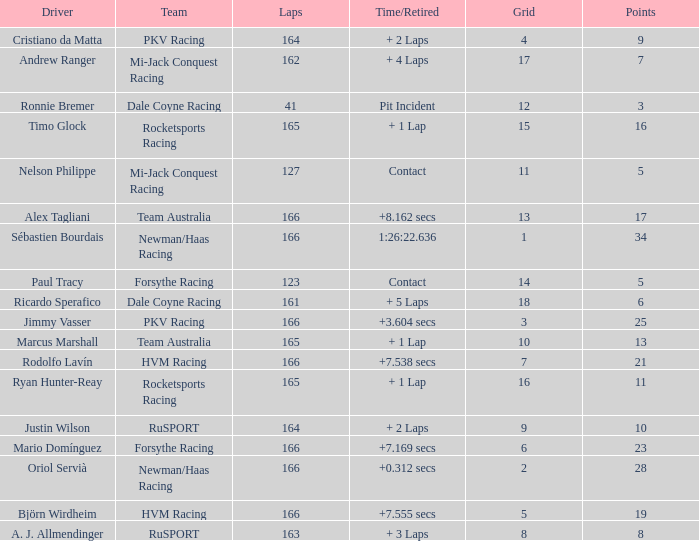Driver Ricardo Sperafico has what as his average laps? 161.0. 